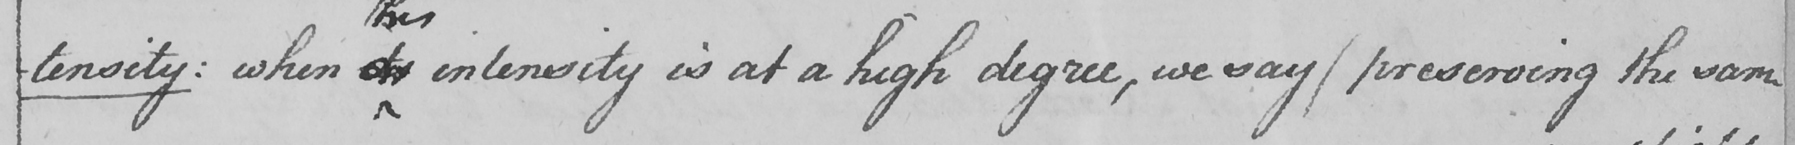Please provide the text content of this handwritten line. -tensity :  when its intensity is at a high degree , we may  ( preserving the same 